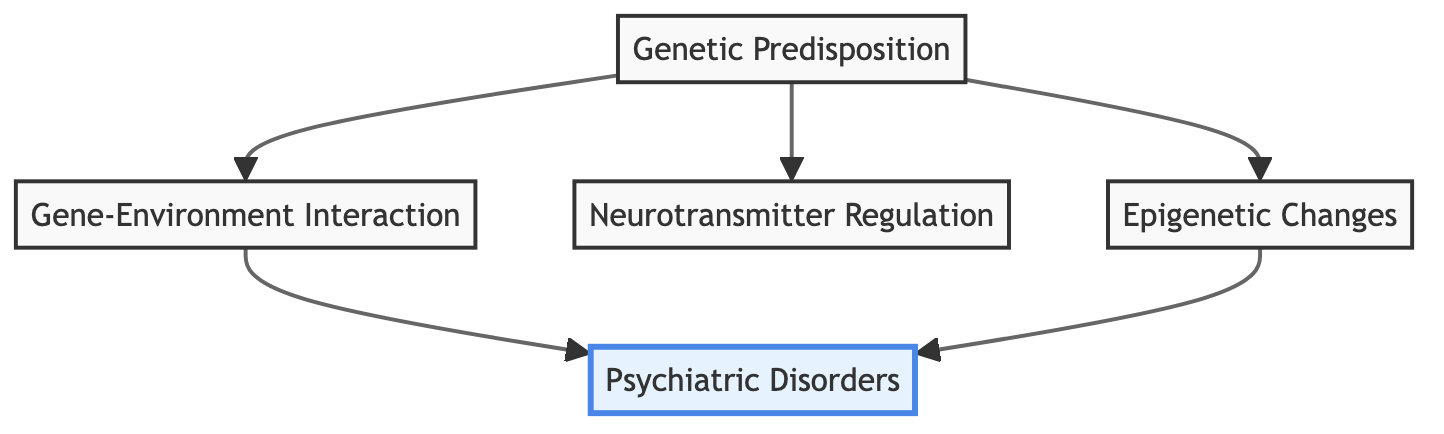What are the four main nodes depicted in the diagram? The diagram consists of five nodes: Genetic Predisposition, Gene-Environment Interaction, Neurotransmitter Regulation, Epigenetic Changes, and Psychiatric Disorders.
Answer: Genetic Predisposition, Gene-Environment Interaction, Neurotransmitter Regulation, Epigenetic Changes How many edges are present in the diagram? The diagram has five edges connecting the nodes: Genetic Predisposition to Gene-Environment Interaction, Gene-Environment Interaction to Psychiatric Disorders, Genetic Predisposition to Neurotransmitter Regulation, Genetic Predisposition to Epigenetic Changes, and Epigenetic Changes to Psychiatric Disorders.
Answer: 5 Which node is highlighted in the graph? The highlight is on the node labeled Psychiatric Disorders, which is visually distinct from the other nodes in the diagram.
Answer: Psychiatric Disorders What is the relationship between Genetic Predisposition and Psychiatric Disorders? Genetic Predisposition influences both Gene-Environment Interaction and Neurotransmitter Regulation, which ultimately leads to the development of Psychiatric Disorders through the connections in the diagram.
Answer: Genetic Predisposition influences Psychiatric Disorders Which two nodes have a direct influence on Psychiatric Disorders? The direct influences on Psychiatric Disorders come from the Gene-Environment Interaction and Epigenetic Changes, which are both linked directly to it in the diagram.
Answer: Gene-Environment Interaction, Epigenetic Changes What type of changes can occur due to environmental influences according to the diagram? The diagram indicates that Epigenetic Changes are chemical modifications to DNA that can occur as a result of environmental influences, affecting gene expression and potentially leading to psychiatric disorders.
Answer: Epigenetic Changes Which node connects to Gene-Environment Interaction? Only one node connects directly to Gene-Environment Interaction, which is Genetic Predisposition. This establishes a direct cause-effect relationship between genetic factors and environmental triggers.
Answer: Genetic Predisposition Which node influences Neurotransmitter Regulation? The node Genetic Predisposition influences Neurotransmitter Regulation directly, as indicated by the directed edge in the diagram. This suggests that genetic factors play a role in the regulation of neurotransmitter systems.
Answer: Genetic Predisposition What is the downstream effect of Epigenetic Changes in the diagram? Epigenetic Changes have a downstream effect directly connecting to Psychiatric Disorders, indicating that these changes can lead to the development of various psychiatric conditions.
Answer: Psychiatric Disorders 